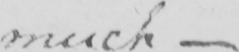Can you tell me what this handwritten text says? much  _ 